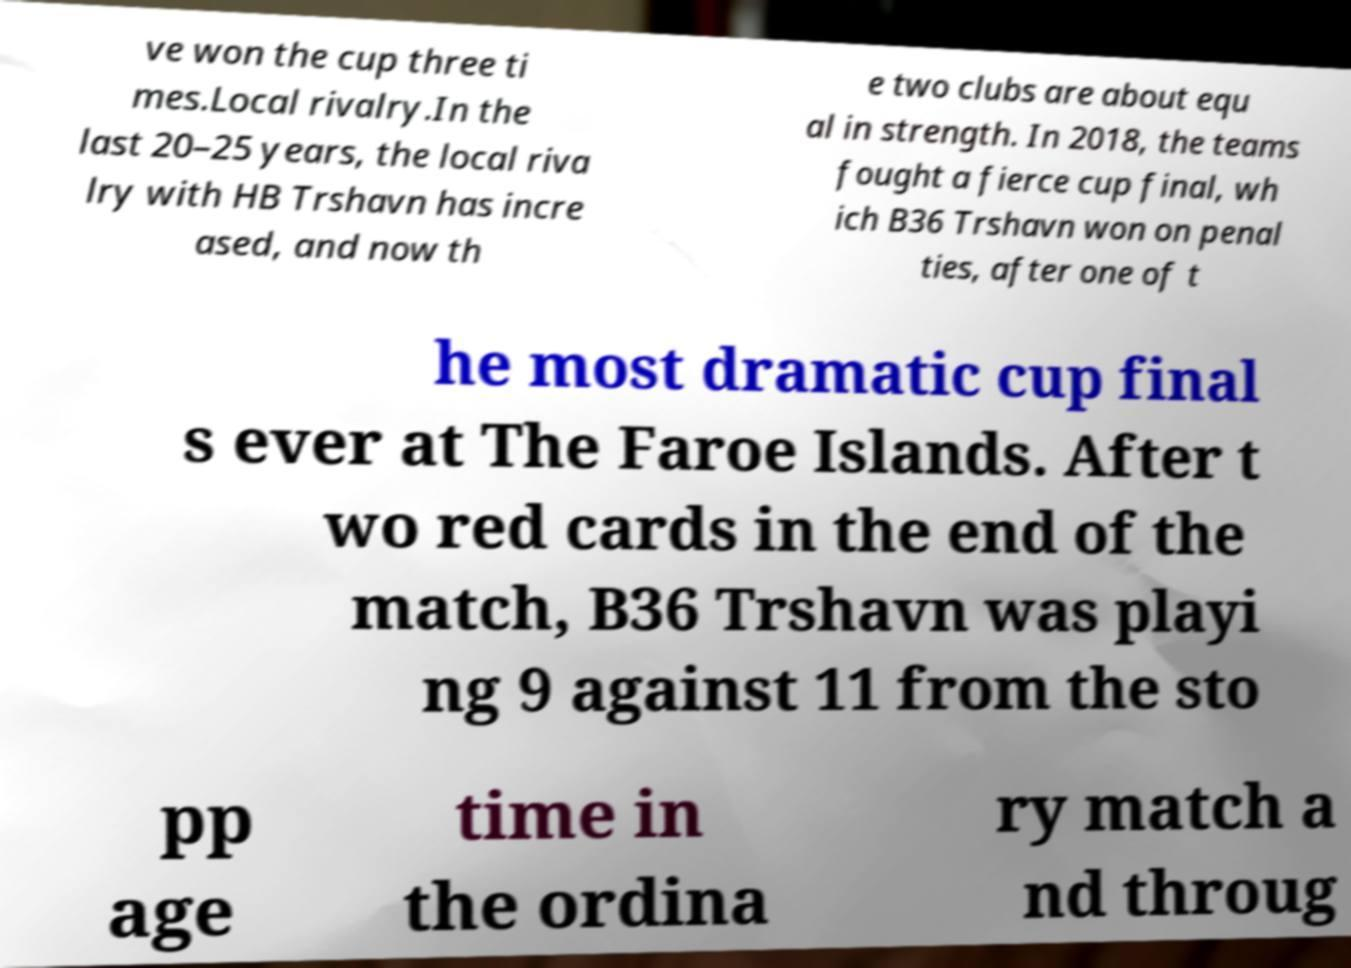There's text embedded in this image that I need extracted. Can you transcribe it verbatim? ve won the cup three ti mes.Local rivalry.In the last 20–25 years, the local riva lry with HB Trshavn has incre ased, and now th e two clubs are about equ al in strength. In 2018, the teams fought a fierce cup final, wh ich B36 Trshavn won on penal ties, after one of t he most dramatic cup final s ever at The Faroe Islands. After t wo red cards in the end of the match, B36 Trshavn was playi ng 9 against 11 from the sto pp age time in the ordina ry match a nd throug 